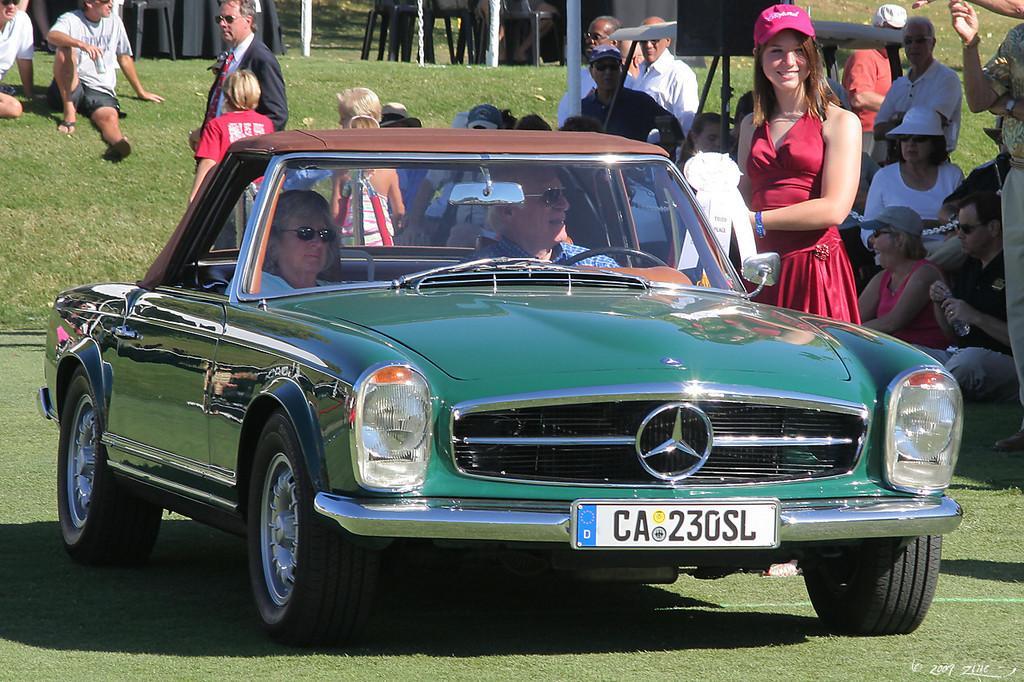Describe this image in one or two sentences. In this image we can see a car in which two persons are sitting in it. In the background we can see few people sitting on the ground. 